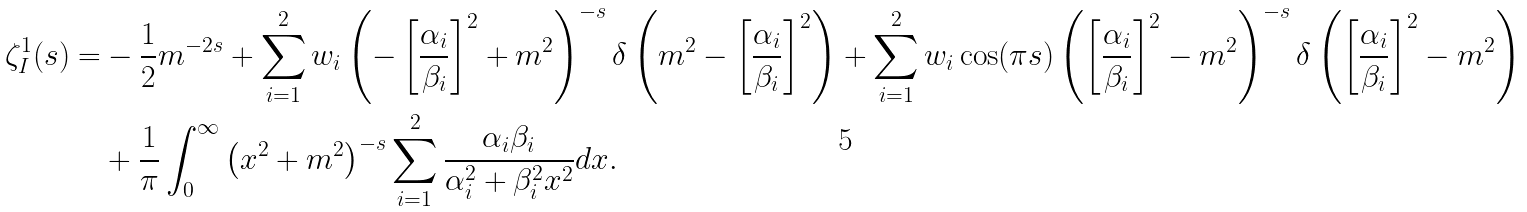<formula> <loc_0><loc_0><loc_500><loc_500>\zeta _ { I } ^ { 1 } ( s ) = & - \frac { 1 } { 2 } m ^ { - 2 s } + \sum _ { i = 1 } ^ { 2 } w _ { i } \left ( - \left [ \frac { \alpha _ { i } } { \beta _ { i } } \right ] ^ { 2 } + m ^ { 2 } \right ) ^ { - s } \delta \left ( m ^ { 2 } - \left [ \frac { \alpha _ { i } } { \beta _ { i } } \right ] ^ { 2 } \right ) + \sum _ { i = 1 } ^ { 2 } w _ { i } \cos ( \pi s ) \left ( \left [ \frac { \alpha _ { i } } { \beta _ { i } } \right ] ^ { 2 } - m ^ { 2 } \right ) ^ { - s } \delta \left ( \left [ \frac { \alpha _ { i } } { \beta _ { i } } \right ] ^ { 2 } - m ^ { 2 } \right ) \\ & + \frac { 1 } { \pi } \int _ { 0 } ^ { \infty } \left ( x ^ { 2 } + m ^ { 2 } \right ) ^ { - s } \sum _ { i = 1 } ^ { 2 } \frac { \alpha _ { i } \beta _ { i } } { \alpha _ { i } ^ { 2 } + \beta _ { i } ^ { 2 } x ^ { 2 } } d x .</formula> 